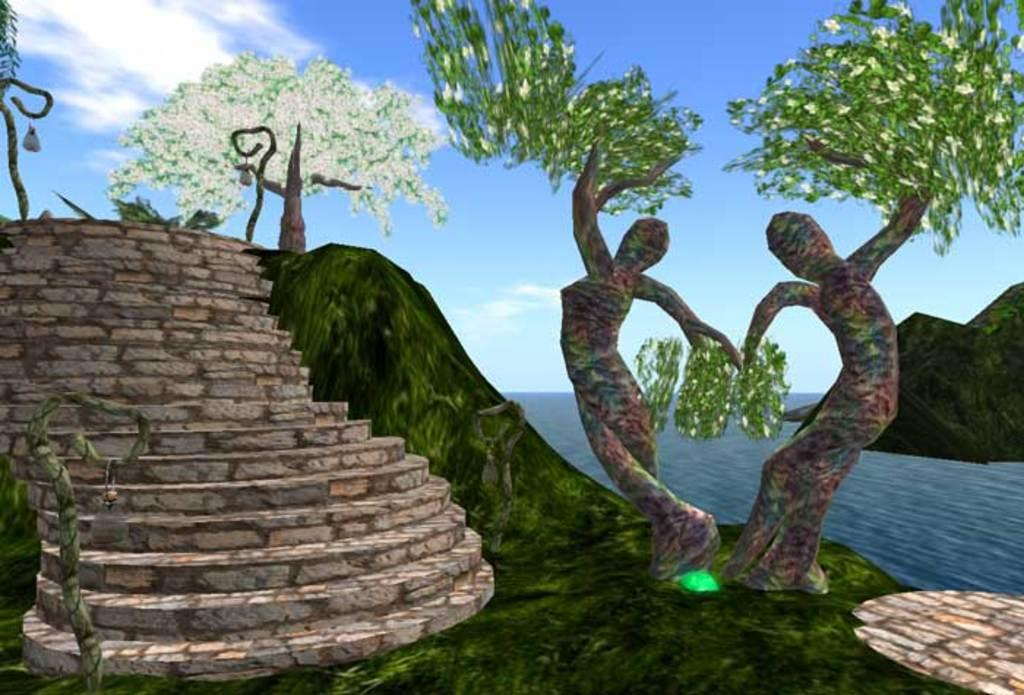What type of image is this? The image appears to be animated. What can be seen on the right side of the image? There are trees on the right side of the image. What architectural feature is present on the left side of the image? There are steps on the left side of the image. What is visible in the sky at the top of the image? There are clouds visible in the sky at the top of the image. What type of net is being used for teaching in the image? There is no net or teaching activity present in the image. What button is being pushed by the clouds in the image? There is no button present in the image, and the clouds are not interacting with any objects. 